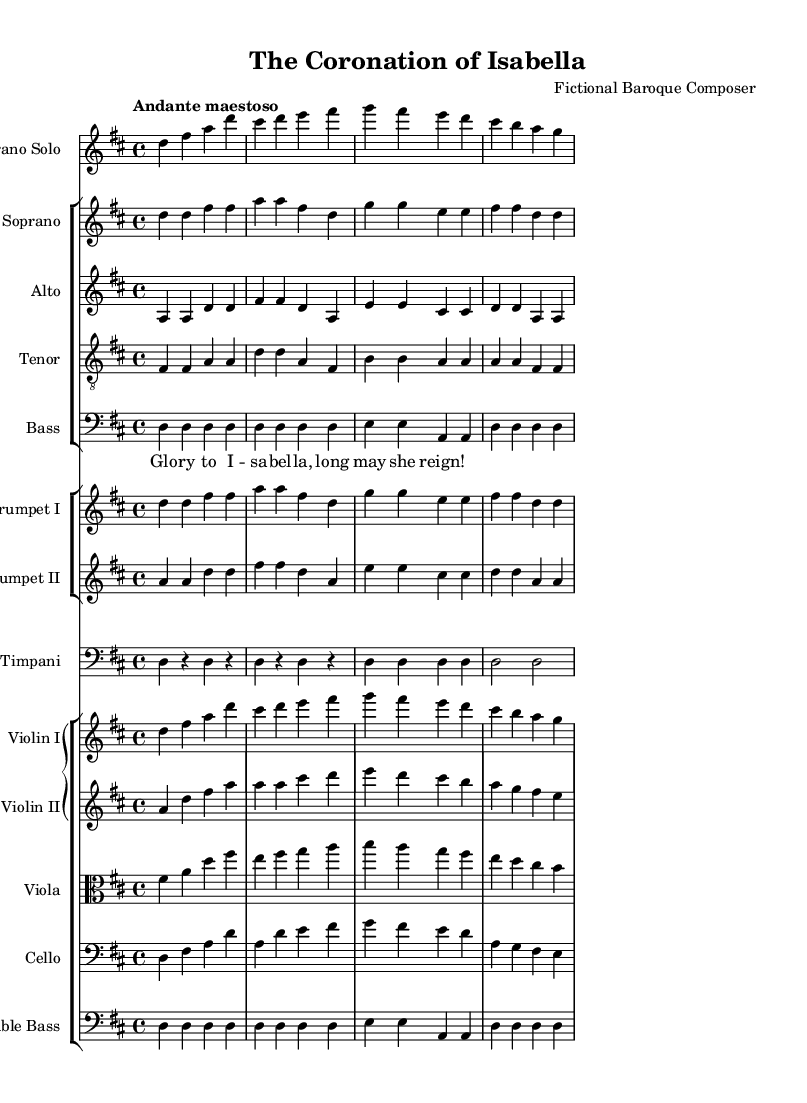What is the key signature of this music? The key signature is identified by the sharp or flat symbols at the beginning of the staff. In this case, there are two sharps, indicating that the key is D major.
Answer: D major What is the time signature of this music? The time signature is determined by the numbers at the beginning of the staff, with the top number representing beats per measure and the bottom number indicating the note value. Here, the time signature is 4/4, meaning there are four beats per measure, and the quarter note gets one beat.
Answer: 4/4 What is the tempo marking given for this piece? The tempo marking is provided in Italian at the beginning of the score, indicating the speed at which the music should be played. In this case, "Andante maestoso" suggests a moderately slow and majestic pace.
Answer: Andante maestoso How many different voice parts are in the choir? The choir consists of four distinct voice parts: soprano, alto, tenor, and bass, as indicated by the individual staff labels for each part.
Answer: Four Identify a musical instrument featured in this oratorio. The score features various instruments; one of them can be found in the group labeled "Trumpet I", confirming the use of the trumpet as part of the orchestration.
Answer: Trumpet What thematic element is depicted in the chorus lyrics? The chorus lyrics specifically highlight praise for a monarch, in this case celebrating Isabella, suggesting the religious reverence often present in oratorios relating to Catholic monarchs.
Answer: Glory to Isabella What is the structure of the instrumental accompaniment in this piece? The instrumental accompaniment is composed of strings and brass, with considerable participation from violins, violas, celli, double basses, and trumpets as indicated in their notation, creating a rich texture typical in Baroque oratorios.
Answer: Strings and brass 